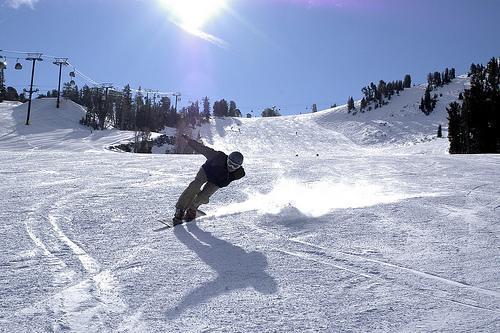How many people are in this picture?
Give a very brief answer. 1. 